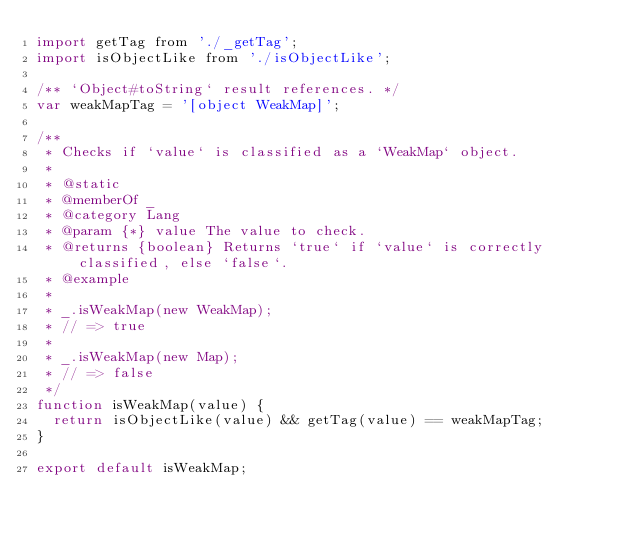<code> <loc_0><loc_0><loc_500><loc_500><_JavaScript_>import getTag from './_getTag';
import isObjectLike from './isObjectLike';

/** `Object#toString` result references. */
var weakMapTag = '[object WeakMap]';

/**
 * Checks if `value` is classified as a `WeakMap` object.
 *
 * @static
 * @memberOf _
 * @category Lang
 * @param {*} value The value to check.
 * @returns {boolean} Returns `true` if `value` is correctly classified, else `false`.
 * @example
 *
 * _.isWeakMap(new WeakMap);
 * // => true
 *
 * _.isWeakMap(new Map);
 * // => false
 */
function isWeakMap(value) {
  return isObjectLike(value) && getTag(value) == weakMapTag;
}

export default isWeakMap;
</code> 